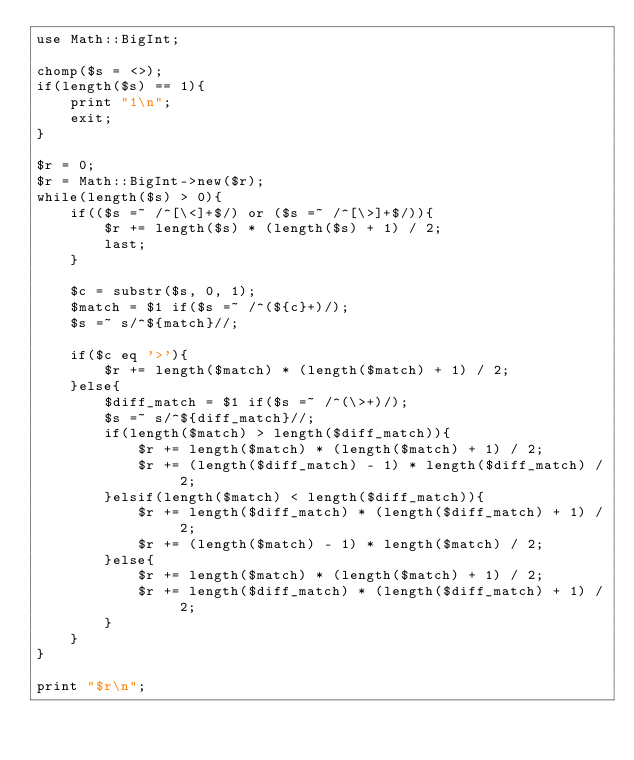Convert code to text. <code><loc_0><loc_0><loc_500><loc_500><_Perl_>use Math::BigInt;

chomp($s = <>);
if(length($s) == 1){
	print "1\n";
	exit;
}

$r = 0;
$r = Math::BigInt->new($r);
while(length($s) > 0){
	if(($s =~ /^[\<]+$/) or ($s =~ /^[\>]+$/)){
		$r += length($s) * (length($s) + 1) / 2;
		last;
	}

	$c = substr($s, 0, 1);
	$match = $1 if($s =~ /^(${c}+)/);
	$s =~ s/^${match}//;

	if($c eq '>'){
		$r += length($match) * (length($match) + 1) / 2;
	}else{
		$diff_match = $1 if($s =~ /^(\>+)/);
		$s =~ s/^${diff_match}//;
		if(length($match) > length($diff_match)){
			$r += length($match) * (length($match) + 1) / 2;
			$r += (length($diff_match) - 1) * length($diff_match) / 2;
		}elsif(length($match) < length($diff_match)){
			$r += length($diff_match) * (length($diff_match) + 1) / 2;
			$r += (length($match) - 1) * length($match) / 2;
		}else{
			$r += length($match) * (length($match) + 1) / 2;
			$r += length($diff_match) * (length($diff_match) + 1) / 2;
		}
	}
}

print "$r\n";
</code> 